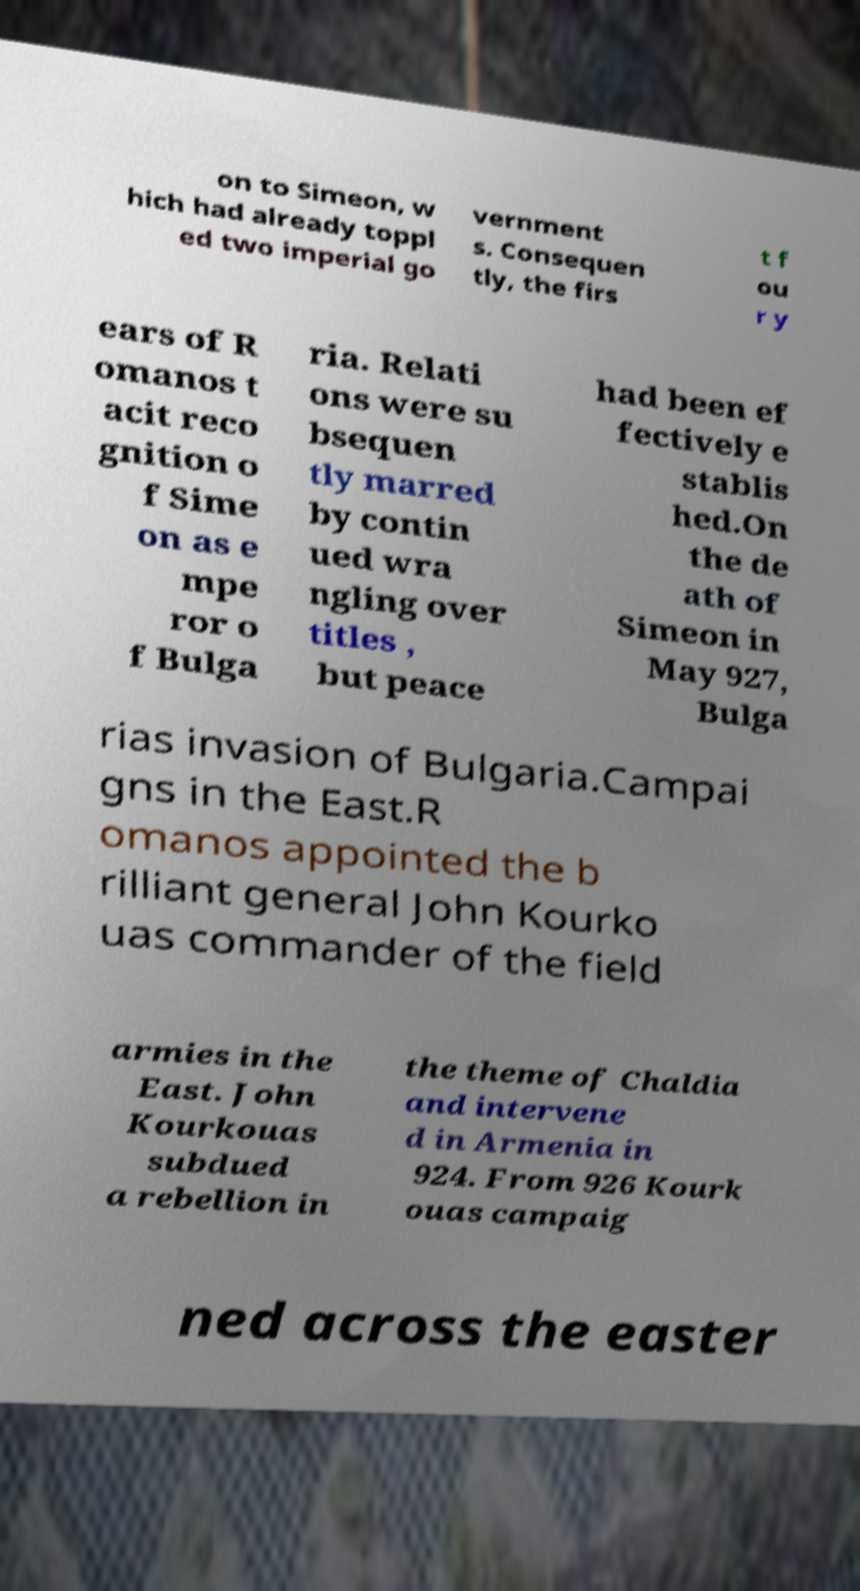Could you extract and type out the text from this image? on to Simeon, w hich had already toppl ed two imperial go vernment s. Consequen tly, the firs t f ou r y ears of R omanos t acit reco gnition o f Sime on as e mpe ror o f Bulga ria. Relati ons were su bsequen tly marred by contin ued wra ngling over titles , but peace had been ef fectively e stablis hed.On the de ath of Simeon in May 927, Bulga rias invasion of Bulgaria.Campai gns in the East.R omanos appointed the b rilliant general John Kourko uas commander of the field armies in the East. John Kourkouas subdued a rebellion in the theme of Chaldia and intervene d in Armenia in 924. From 926 Kourk ouas campaig ned across the easter 